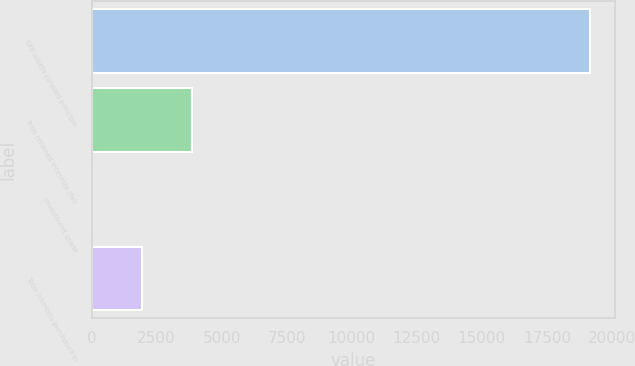Convert chart. <chart><loc_0><loc_0><loc_500><loc_500><bar_chart><fcel>SPE assets (unpaid principal<fcel>Total retained interests (fair<fcel>Investment grade<fcel>Total interests purchased in<nl><fcel>19155<fcel>3847.8<fcel>21<fcel>1934.4<nl></chart> 